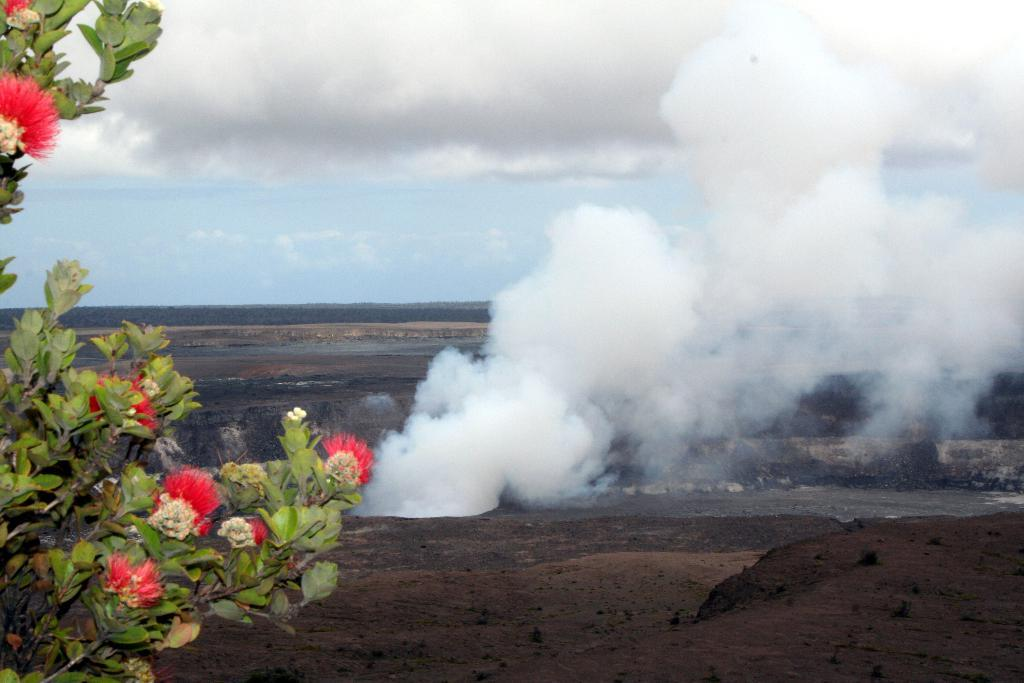What type of plant life can be seen in the image? There are flowers and leaves in the image. What else is visible in the image besides plant life? There is smoke in the image. What can be seen in the background of the image? The sky is visible in the background of the image, and clouds are present in the sky. Where is the shelf located in the image? There is no shelf present in the image. How does the transport system function in the image? There is no transport system present in the image. 